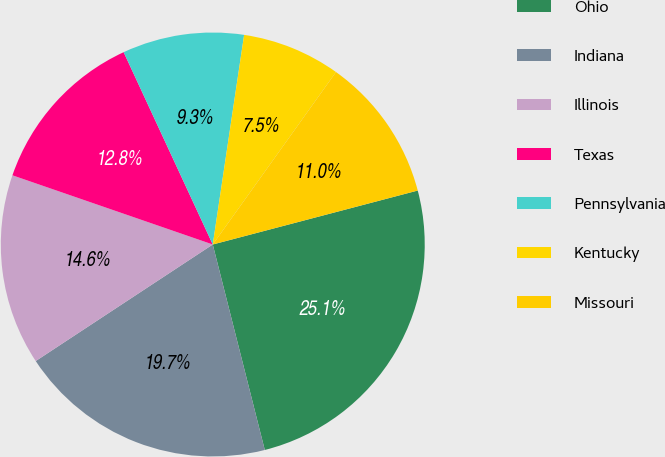Convert chart to OTSL. <chart><loc_0><loc_0><loc_500><loc_500><pie_chart><fcel>Ohio<fcel>Indiana<fcel>Illinois<fcel>Texas<fcel>Pennsylvania<fcel>Kentucky<fcel>Missouri<nl><fcel>25.15%<fcel>19.68%<fcel>14.56%<fcel>12.8%<fcel>9.27%<fcel>7.51%<fcel>11.03%<nl></chart> 